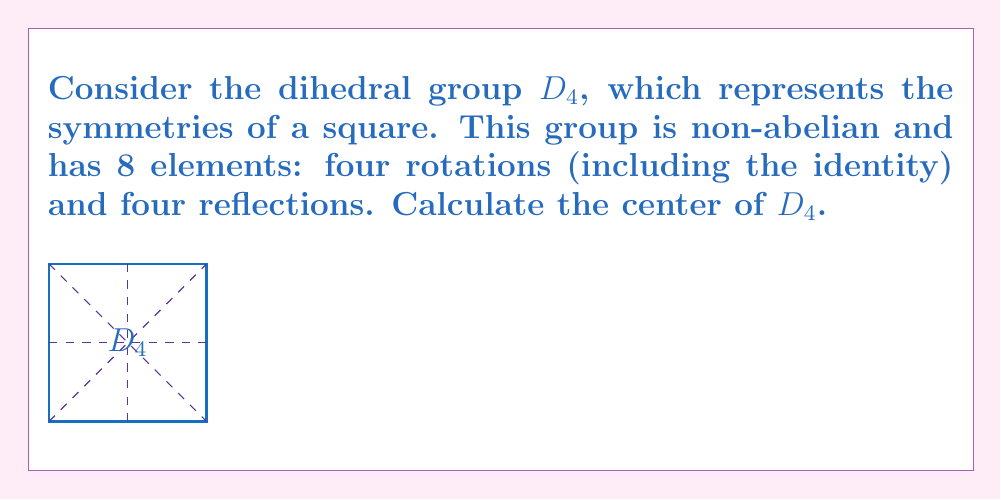Solve this math problem. To calculate the center of $D_4$, we need to follow these steps:

1) Recall that the center of a group $G$ is defined as:
   $$Z(G) = \{z \in G : zg = gz \text{ for all } g \in G\}$$

2) In $D_4$, let's denote:
   - $r$ as a 90° clockwise rotation
   - $s$ as a reflection about a diagonal

3) The elements of $D_4$ are: $\{e, r, r^2, r^3, s, sr, sr^2, sr^3\}$

4) We need to find which elements commute with all other elements:

   a) $e$ (identity) commutes with everything
   b) $r^2$ (180° rotation) commutes with everything
   c) All other rotations don't commute with reflections
   d) Reflections don't commute with rotations (except $r^2$) or other reflections

5) Therefore, the center of $D_4$ consists of $\{e, r^2\}$

This result shows that in the symmetric group of a square, only the identity and the 180° rotation commute with all other symmetries.
Answer: $Z(D_4) = \{e, r^2\}$ 